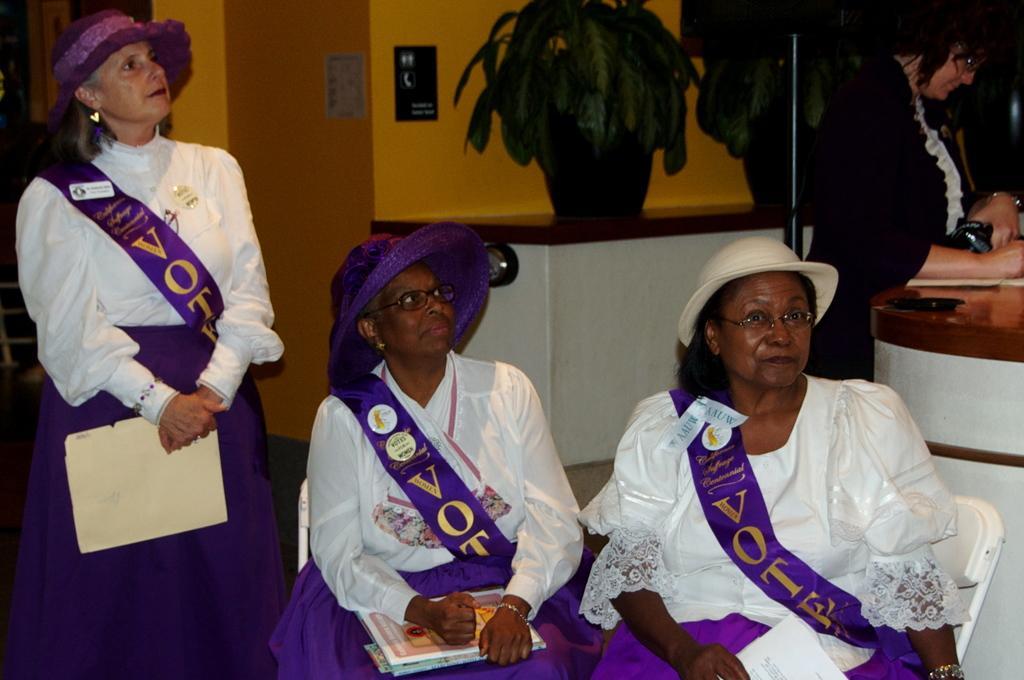How would you summarize this image in a sentence or two? In this image there are three persons wearing sashes and caps and holding papers, behind them there is a person near the TV stand, a flower pot on one of the tables and posters attached to the wall. 